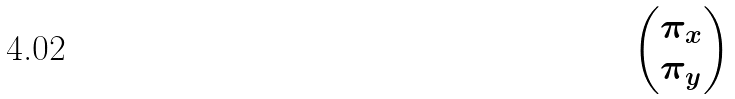Convert formula to latex. <formula><loc_0><loc_0><loc_500><loc_500>\begin{pmatrix} \pi _ { x } \\ \pi _ { y } \end{pmatrix}</formula> 